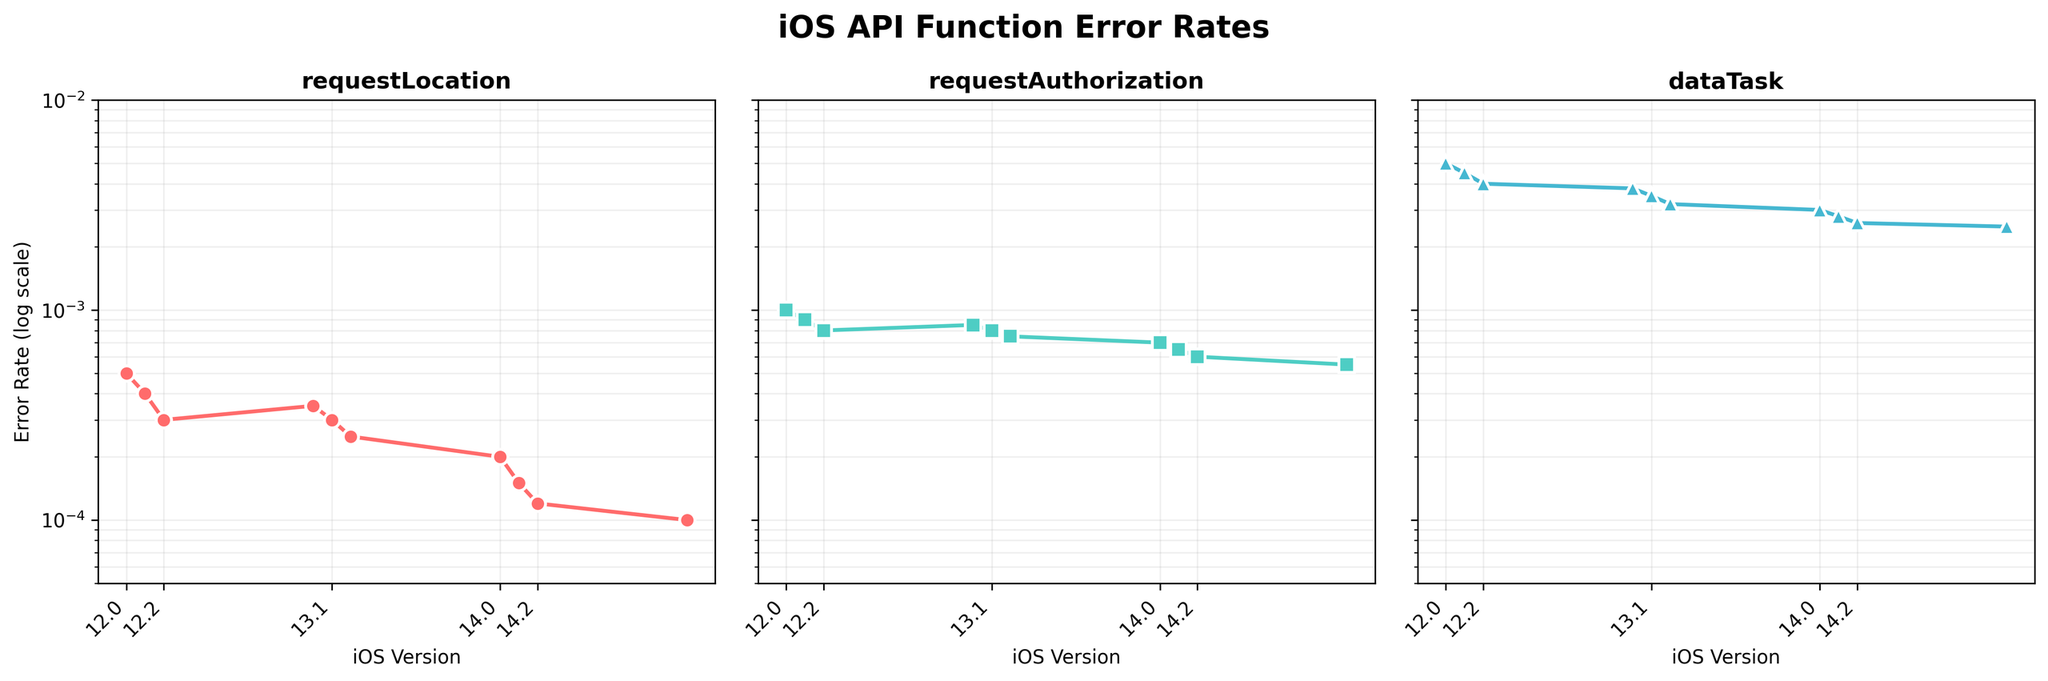What is the title of the figure? The title is presented at the top of the figure. It reads "iOS API Function Error Rates" in bold font.
Answer: iOS API Function Error Rates Which API function has the lowest error rate for iOS version 15.0? By examining the endpoints of the plots in the last column (iOS version 15.0), "CLLocationManager.requestLocation" has the lowest value.
Answer: CLLocationManager.requestLocation How many iOS versions are represented in the figure? The x-axis of each subplot shows the tick marks for each iOS version. Each API plot has 10 iOS versions marked.
Answer: 10 Describe the trend in error rates for the "UserNotifications.requestAuthorization" API function across iOS versions. The plot shows a downward trend with error rates decreasing from 0.001 in iOS 12.0 to 0.00055 in iOS 15.0.
Answer: Downward trend What is the error rate of "URLSession.dataTask" at iOS version 13.0? By observing the point marked on the "URLSession.dataTask" subplot at iOS version 13.0, the error rate is around 0.0038.
Answer: 0.0038 Compare the error rates of "CLLocationManager.requestLocation" and "UserNotifications.requestAuthorization" at iOS version 13.1. Which one is higher? At iOS version 13.1, the "UserNotifications.requestAuthorization" error rate is slightly higher (0.0008) compared to "CLLocationManager.requestLocation" (0.0003).
Answer: UserNotifications.requestAuthorization How does the error rate change for "URLSession.dataTask" from iOS version 12.0 to 12.2? The error rate for "URLSession.dataTask" decreases from 0.005 in iOS version 12.0 to 0.004 in iOS version 12.2.
Answer: Decreases What is the log scale range of the y-axis? The y-axis is plotted on a log scale, spanning from 0.00005 to 0.01 as labeled on the axis.
Answer: 0.00005 to 0.01 Are the error rates for all API functions decreasing consistently across iOS versions? Yes, all three API functions show a consistently decreasing error rate from iOS version 12.0 to 15.0 as observed in their respective subplots.
Answer: Yes Which API function shows the smallest change in error rate between iOS version 14.2 and 15.0? By closely examining the endpoints between iOS 14.2 and 15.0, "CLLocationManager.requestLocation" shows a minor change from 0.00012 to 0.0001.
Answer: CLLocationManager.requestLocation 